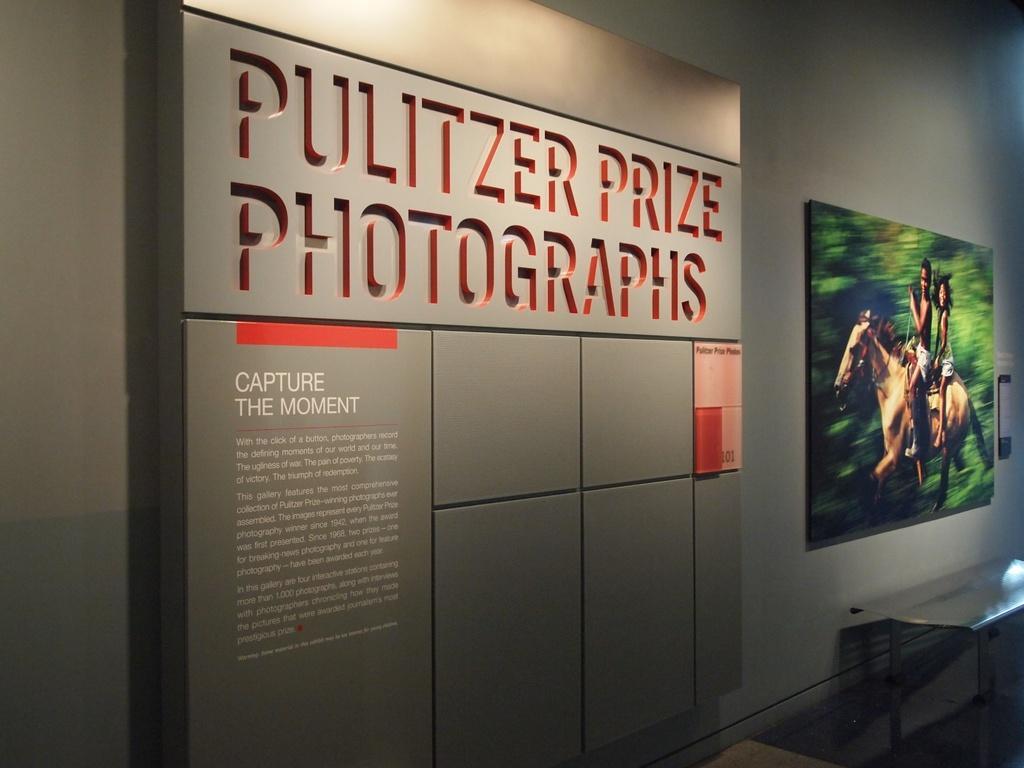Could you give a brief overview of what you see in this image? This image consists of a photo frame on the right side. There is something written in the middle. 